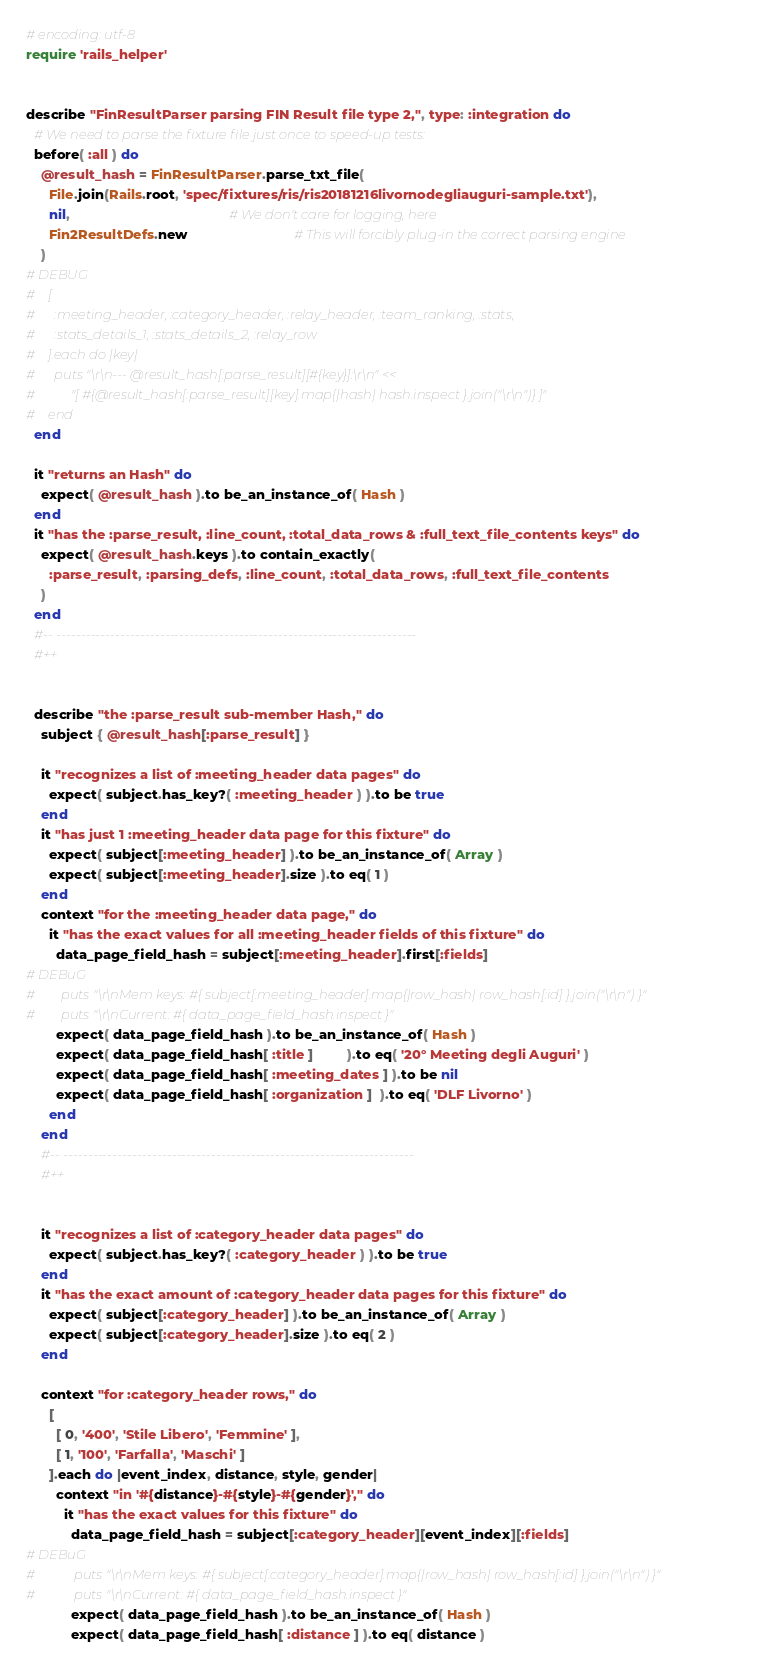<code> <loc_0><loc_0><loc_500><loc_500><_Ruby_># encoding: utf-8
require 'rails_helper'


describe "FinResultParser parsing FIN Result file type 2,", type: :integration do
  # We need to parse the fixture file just once to speed-up tests:
  before( :all ) do
    @result_hash = FinResultParser.parse_txt_file(
      File.join(Rails.root, 'spec/fixtures/ris/ris20181216livornodegliauguri-sample.txt'),
      nil,                                          # We don't care for logging, here
      Fin2ResultDefs.new                            # This will forcibly plug-in the correct parsing engine
    )
# DEBUG
#    [
#      :meeting_header, :category_header, :relay_header, :team_ranking, :stats,
#      :stats_details_1, :stats_details_2, :relay_row
#    ].each do |key|
#      puts "\r\n--- @result_hash[:parse_result][#{key}]:\r\n" <<
#           "[ #{@result_hash[:parse_result][key].map{|hash| hash.inspect }.join("\r\n")} ]"
#    end
  end

  it "returns an Hash" do
    expect( @result_hash ).to be_an_instance_of( Hash )
  end
  it "has the :parse_result, :line_count, :total_data_rows & :full_text_file_contents keys" do
    expect( @result_hash.keys ).to contain_exactly(
      :parse_result, :parsing_defs, :line_count, :total_data_rows, :full_text_file_contents
    )
  end
  #-- -------------------------------------------------------------------------
  #++


  describe "the :parse_result sub-member Hash," do
    subject { @result_hash[:parse_result] }

    it "recognizes a list of :meeting_header data pages" do
      expect( subject.has_key?( :meeting_header ) ).to be true
    end
    it "has just 1 :meeting_header data page for this fixture" do
      expect( subject[:meeting_header] ).to be_an_instance_of( Array )
      expect( subject[:meeting_header].size ).to eq( 1 )
    end
    context "for the :meeting_header data page," do
      it "has the exact values for all :meeting_header fields of this fixture" do
        data_page_field_hash = subject[:meeting_header].first[:fields]
# DEBuG
#        puts "\r\nMem keys: #{ subject[:meeting_header].map{|row_hash| row_hash[:id] }.join("\r\n") }"
#        puts "\r\nCurrent: #{ data_page_field_hash.inspect }"
        expect( data_page_field_hash ).to be_an_instance_of( Hash )
        expect( data_page_field_hash[ :title ]         ).to eq( '20° Meeting degli Auguri' )
        expect( data_page_field_hash[ :meeting_dates ] ).to be nil
        expect( data_page_field_hash[ :organization ]  ).to eq( 'DLF Livorno' )
      end
    end
    #-- -----------------------------------------------------------------------
    #++


    it "recognizes a list of :category_header data pages" do
      expect( subject.has_key?( :category_header ) ).to be true
    end
    it "has the exact amount of :category_header data pages for this fixture" do
      expect( subject[:category_header] ).to be_an_instance_of( Array )
      expect( subject[:category_header].size ).to eq( 2 )
    end

    context "for :category_header rows," do
      [
        [ 0, '400', 'Stile Libero', 'Femmine' ],
        [ 1, '100', 'Farfalla', 'Maschi' ]
      ].each do |event_index, distance, style, gender|
        context "in '#{distance}-#{style}-#{gender}'," do
          it "has the exact values for this fixture" do
            data_page_field_hash = subject[:category_header][event_index][:fields]
# DEBuG
#            puts "\r\nMem keys: #{ subject[:category_header].map{|row_hash| row_hash[:id] }.join("\r\n") }"
#            puts "\r\nCurrent: #{ data_page_field_hash.inspect }"
            expect( data_page_field_hash ).to be_an_instance_of( Hash )
            expect( data_page_field_hash[ :distance ] ).to eq( distance )</code> 